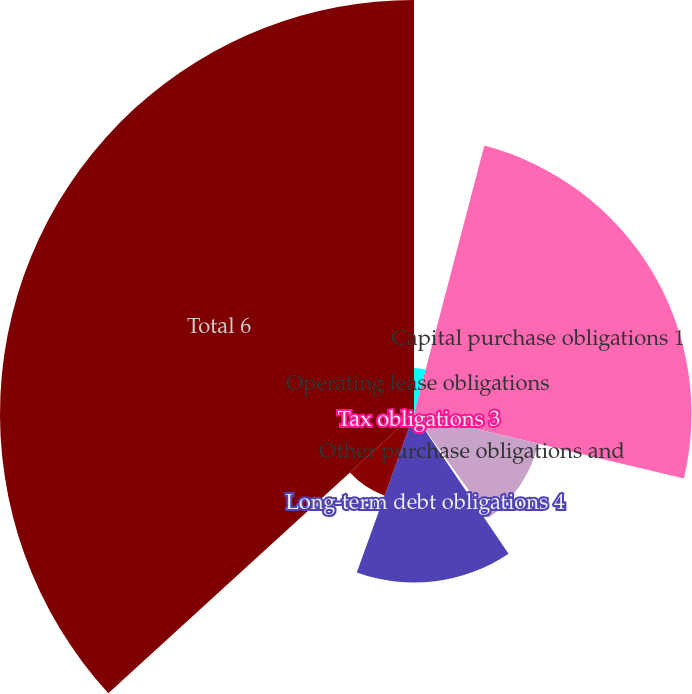Convert chart. <chart><loc_0><loc_0><loc_500><loc_500><pie_chart><fcel>Operating lease obligations<fcel>Capital purchase obligations 1<fcel>Other purchase obligations and<fcel>Tax obligations 3<fcel>Long-term debt obligations 4<fcel>Other long-term liabilities 5<fcel>Total 6<nl><fcel>4.08%<fcel>24.65%<fcel>11.35%<fcel>0.45%<fcel>14.98%<fcel>7.71%<fcel>36.78%<nl></chart> 